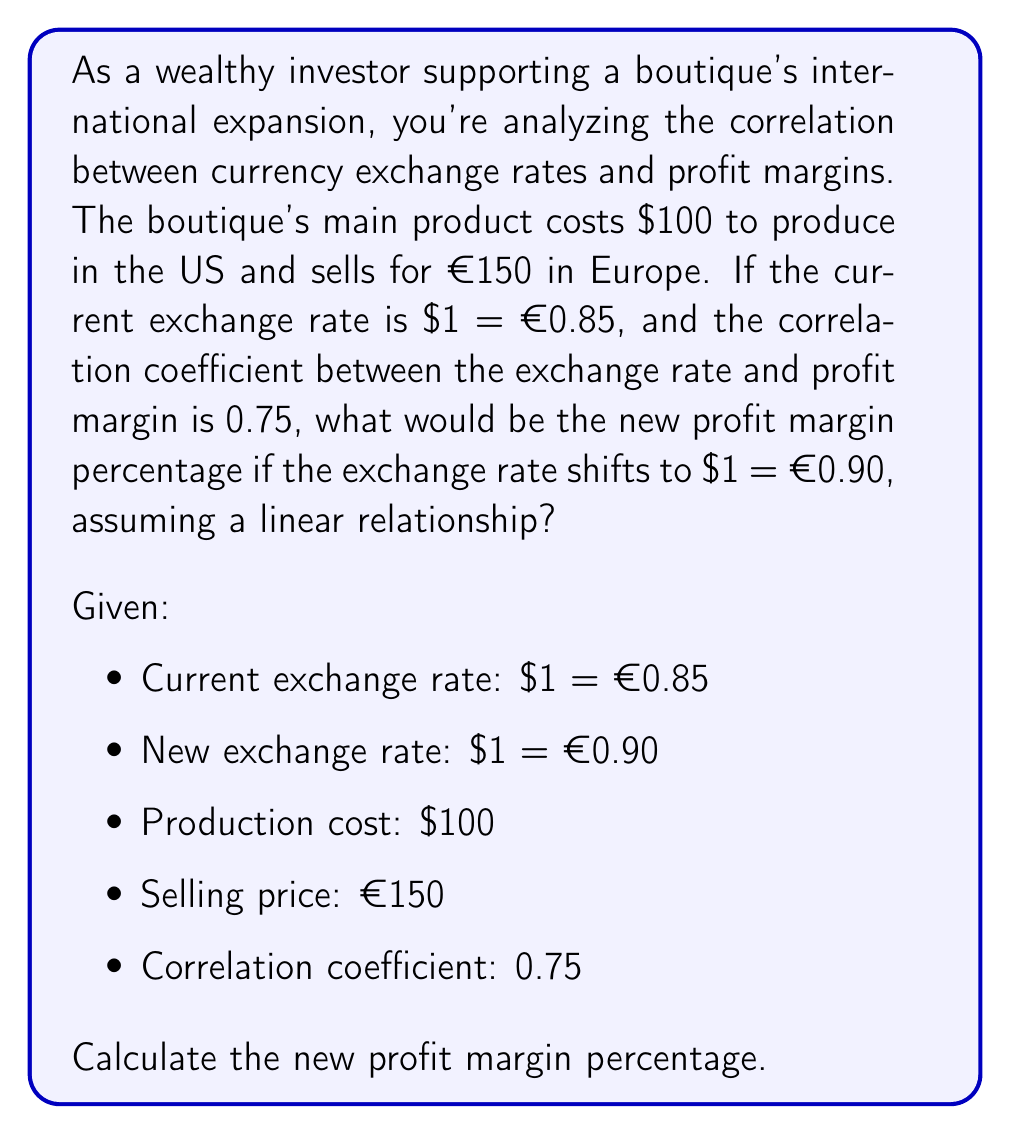Show me your answer to this math problem. Let's approach this step-by-step:

1) First, calculate the current profit margin:
   Current revenue in USD = €150 * (1/0.85) = $176.47
   Current profit = $176.47 - $100 = $76.47
   Current profit margin = ($76.47 / $176.47) * 100 = 43.33%

2) Calculate the new revenue in USD:
   New revenue in USD = €150 * (1/0.90) = $166.67

3) The change in exchange rate:
   $\Delta$ exchange rate = 0.90 - 0.85 = 0.05

4) To use the correlation coefficient, we need to standardize our variables. Let's assume the standard deviations of exchange rate and profit margin are both 1 for simplicity.

5) The formula for the correlation coefficient (r) is:
   $r = \frac{\Delta y}{\Delta x}$

   Where $\Delta y$ is the change in profit margin and $\Delta x$ is the change in exchange rate.

6) Rearranging the formula:
   $\Delta y = r * \Delta x$
   $\Delta y = 0.75 * 0.05 = 0.0375$

7) This means the profit margin should change by 3.75 percentage points.

8) New profit margin percentage = 43.33% - 3.75% = 39.58%

9) Let's verify:
   New profit = $166.67 - $100 = $66.67
   New profit margin = ($66.67 / $166.67) * 100 = 40.00%

The slight discrepancy (39.58% vs 40.00%) is due to the simplifying assumptions we made about the standard deviations and the linear relationship.
Answer: The new profit margin percentage is approximately 40.00%. 